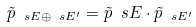Convert formula to latex. <formula><loc_0><loc_0><loc_500><loc_500>\tilde { p } _ { \ s E \oplus \ s E ^ { \prime } } = \tilde { p } _ { \ } s E \cdot \tilde { p } _ { \ s E ^ { \prime } }</formula> 